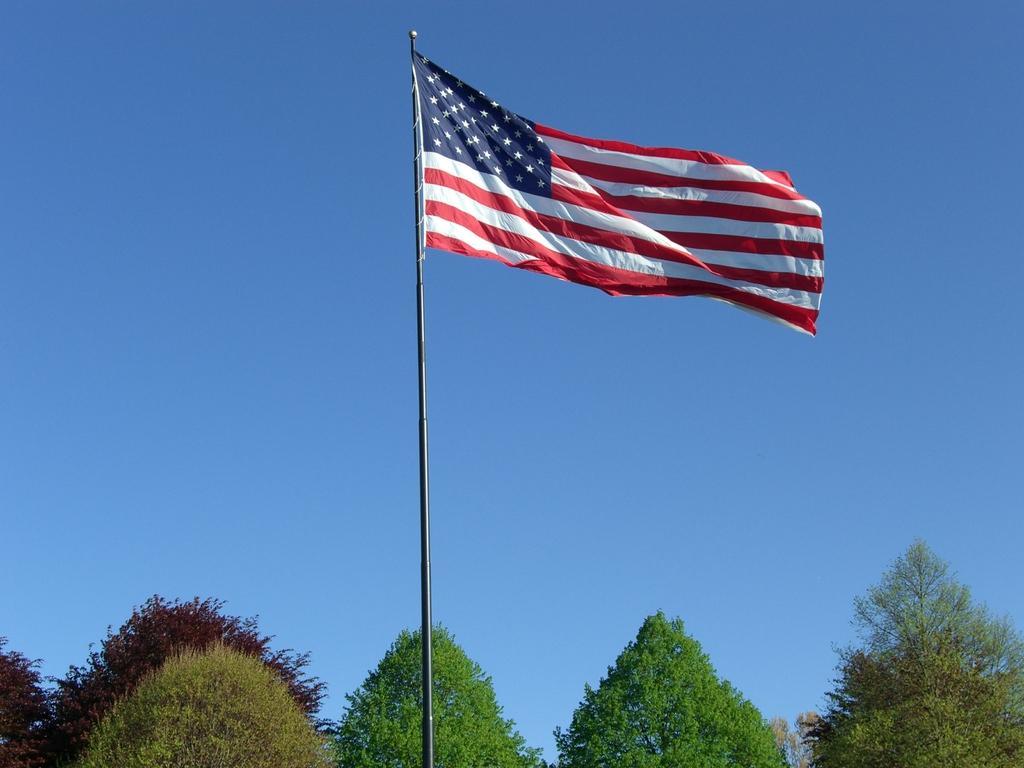Please provide a concise description of this image. In the center of the image there is a flag. In the background of the image there are trees and sky. 